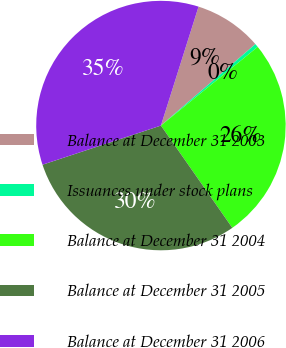Convert chart to OTSL. <chart><loc_0><loc_0><loc_500><loc_500><pie_chart><fcel>Balance at December 31 2003<fcel>Issuances under stock plans<fcel>Balance at December 31 2004<fcel>Balance at December 31 2005<fcel>Balance at December 31 2006<nl><fcel>8.8%<fcel>0.46%<fcel>26.17%<fcel>29.62%<fcel>34.96%<nl></chart> 